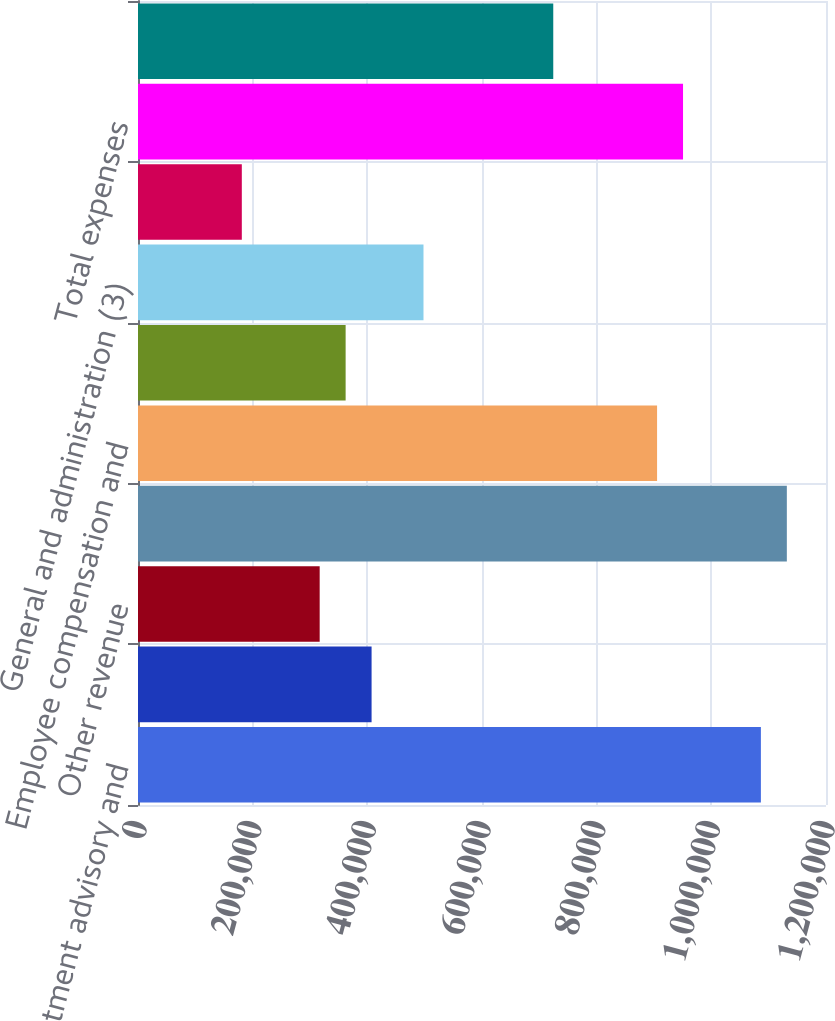<chart> <loc_0><loc_0><loc_500><loc_500><bar_chart><fcel>Investment advisory and<fcel>BlackRock Solutions and<fcel>Other revenue<fcel>Total revenue<fcel>Employee compensation and<fcel>Portfolio administration and<fcel>General and administration (3)<fcel>Amortization of intangible<fcel>Total expenses<fcel>Operating income<nl><fcel>1.08644e+06<fcel>407414<fcel>316878<fcel>1.1317e+06<fcel>905363<fcel>362146<fcel>497950<fcel>181074<fcel>950631<fcel>724290<nl></chart> 